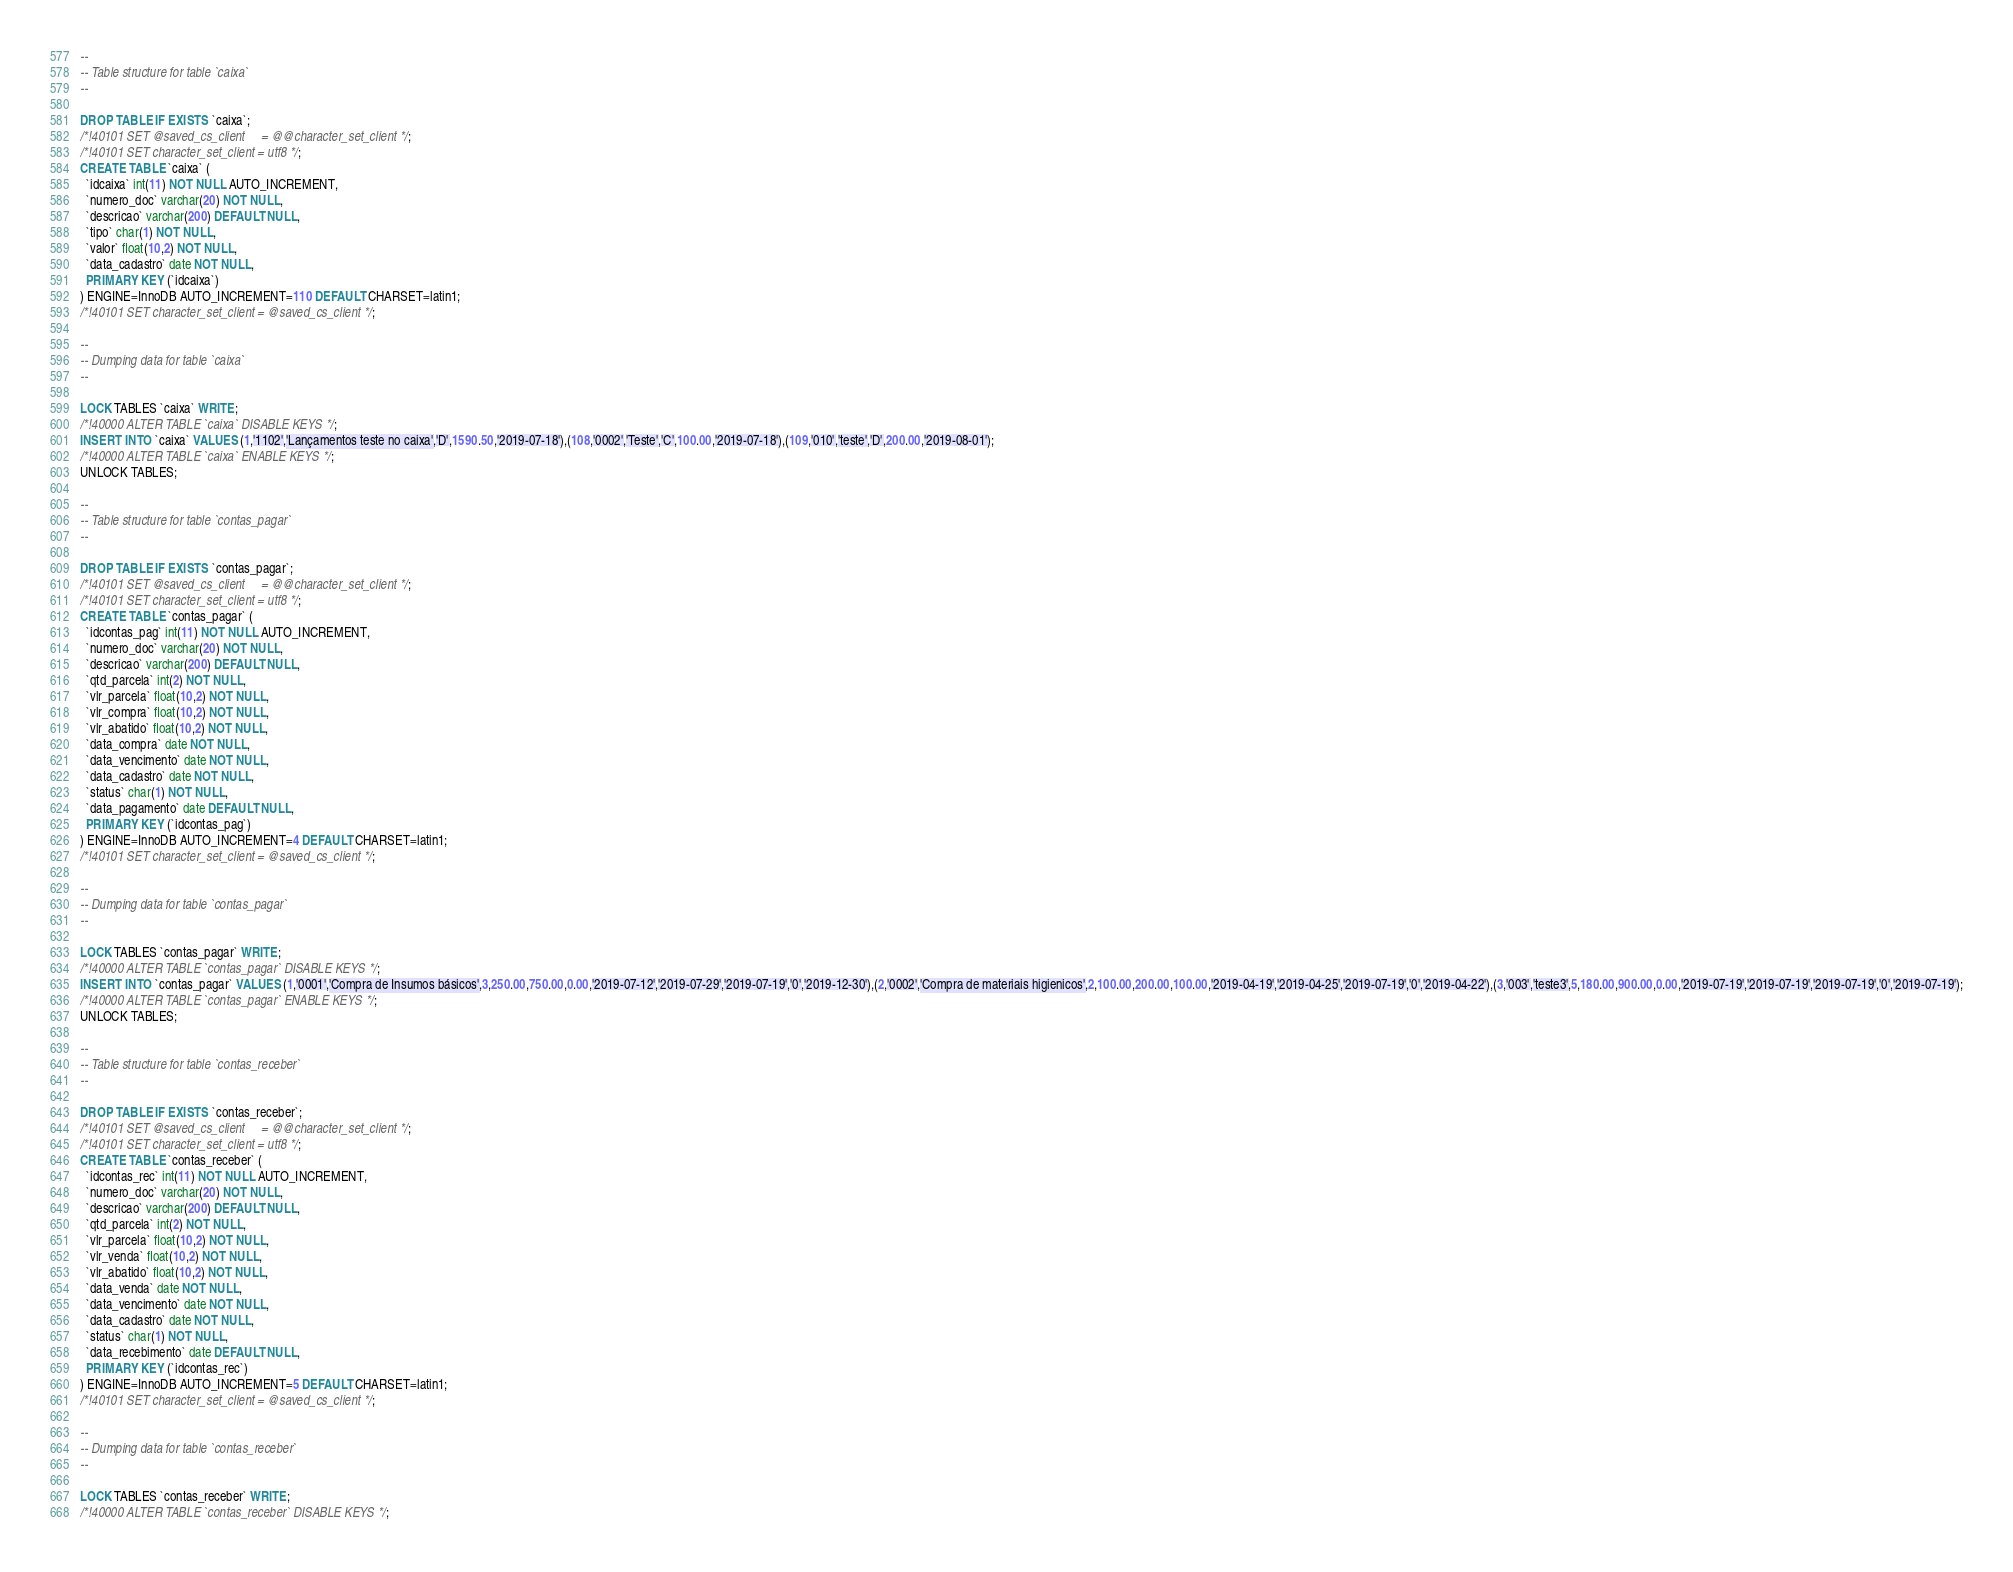<code> <loc_0><loc_0><loc_500><loc_500><_SQL_>--
-- Table structure for table `caixa`
--

DROP TABLE IF EXISTS `caixa`;
/*!40101 SET @saved_cs_client     = @@character_set_client */;
/*!40101 SET character_set_client = utf8 */;
CREATE TABLE `caixa` (
  `idcaixa` int(11) NOT NULL AUTO_INCREMENT,
  `numero_doc` varchar(20) NOT NULL,
  `descricao` varchar(200) DEFAULT NULL,
  `tipo` char(1) NOT NULL,
  `valor` float(10,2) NOT NULL,
  `data_cadastro` date NOT NULL,
  PRIMARY KEY (`idcaixa`)
) ENGINE=InnoDB AUTO_INCREMENT=110 DEFAULT CHARSET=latin1;
/*!40101 SET character_set_client = @saved_cs_client */;

--
-- Dumping data for table `caixa`
--

LOCK TABLES `caixa` WRITE;
/*!40000 ALTER TABLE `caixa` DISABLE KEYS */;
INSERT INTO `caixa` VALUES (1,'1102','Lançamentos teste no caixa','D',1590.50,'2019-07-18'),(108,'0002','Teste','C',100.00,'2019-07-18'),(109,'010','teste','D',200.00,'2019-08-01');
/*!40000 ALTER TABLE `caixa` ENABLE KEYS */;
UNLOCK TABLES;

--
-- Table structure for table `contas_pagar`
--

DROP TABLE IF EXISTS `contas_pagar`;
/*!40101 SET @saved_cs_client     = @@character_set_client */;
/*!40101 SET character_set_client = utf8 */;
CREATE TABLE `contas_pagar` (
  `idcontas_pag` int(11) NOT NULL AUTO_INCREMENT,
  `numero_doc` varchar(20) NOT NULL,
  `descricao` varchar(200) DEFAULT NULL,
  `qtd_parcela` int(2) NOT NULL,
  `vlr_parcela` float(10,2) NOT NULL,
  `vlr_compra` float(10,2) NOT NULL,
  `vlr_abatido` float(10,2) NOT NULL,
  `data_compra` date NOT NULL,
  `data_vencimento` date NOT NULL,
  `data_cadastro` date NOT NULL,
  `status` char(1) NOT NULL,
  `data_pagamento` date DEFAULT NULL,
  PRIMARY KEY (`idcontas_pag`)
) ENGINE=InnoDB AUTO_INCREMENT=4 DEFAULT CHARSET=latin1;
/*!40101 SET character_set_client = @saved_cs_client */;

--
-- Dumping data for table `contas_pagar`
--

LOCK TABLES `contas_pagar` WRITE;
/*!40000 ALTER TABLE `contas_pagar` DISABLE KEYS */;
INSERT INTO `contas_pagar` VALUES (1,'0001','Compra de Insumos básicos',3,250.00,750.00,0.00,'2019-07-12','2019-07-29','2019-07-19','0','2019-12-30'),(2,'0002','Compra de materiais higienicos',2,100.00,200.00,100.00,'2019-04-19','2019-04-25','2019-07-19','0','2019-04-22'),(3,'003','teste3',5,180.00,900.00,0.00,'2019-07-19','2019-07-19','2019-07-19','0','2019-07-19');
/*!40000 ALTER TABLE `contas_pagar` ENABLE KEYS */;
UNLOCK TABLES;

--
-- Table structure for table `contas_receber`
--

DROP TABLE IF EXISTS `contas_receber`;
/*!40101 SET @saved_cs_client     = @@character_set_client */;
/*!40101 SET character_set_client = utf8 */;
CREATE TABLE `contas_receber` (
  `idcontas_rec` int(11) NOT NULL AUTO_INCREMENT,
  `numero_doc` varchar(20) NOT NULL,
  `descricao` varchar(200) DEFAULT NULL,
  `qtd_parcela` int(2) NOT NULL,
  `vlr_parcela` float(10,2) NOT NULL,
  `vlr_venda` float(10,2) NOT NULL,
  `vlr_abatido` float(10,2) NOT NULL,
  `data_venda` date NOT NULL,
  `data_vencimento` date NOT NULL,
  `data_cadastro` date NOT NULL,
  `status` char(1) NOT NULL,
  `data_recebimento` date DEFAULT NULL,
  PRIMARY KEY (`idcontas_rec`)
) ENGINE=InnoDB AUTO_INCREMENT=5 DEFAULT CHARSET=latin1;
/*!40101 SET character_set_client = @saved_cs_client */;

--
-- Dumping data for table `contas_receber`
--

LOCK TABLES `contas_receber` WRITE;
/*!40000 ALTER TABLE `contas_receber` DISABLE KEYS */;</code> 